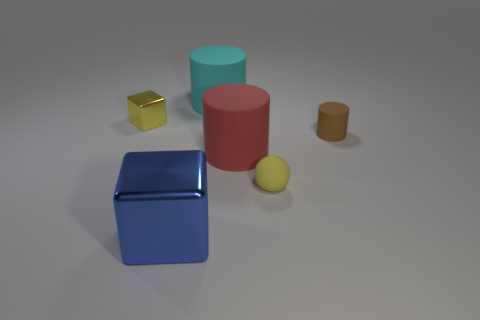What might be the context or purpose of this arrangement of shapes? This image appears to be a 3D rendering that may be used for visual or artistic purposes, such as a study of shapes, colors, and textures in graphic design or a demonstration for teaching geometric concepts. 